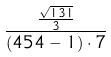<formula> <loc_0><loc_0><loc_500><loc_500>\frac { \frac { \sqrt { 1 3 1 } } { 3 } } { ( 4 5 4 - 1 ) \cdot 7 }</formula> 